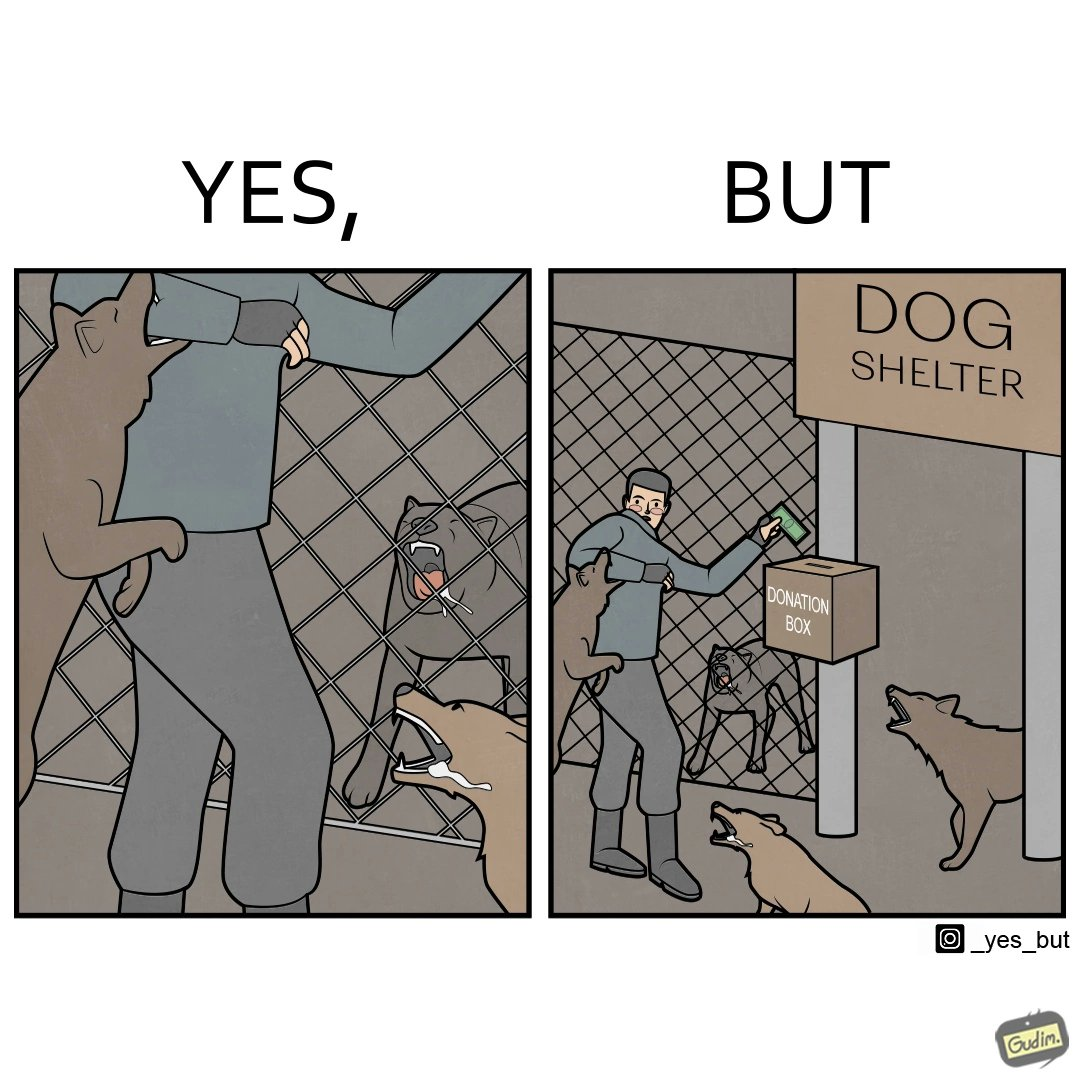Compare the left and right sides of this image. In the left part of the image: It is a man donating money to a dog shelter while dogs are barking at him In the right part of the image: It is a man donating money to a dog shelter while dogs are barking at him and one of the dogs is attacking him 